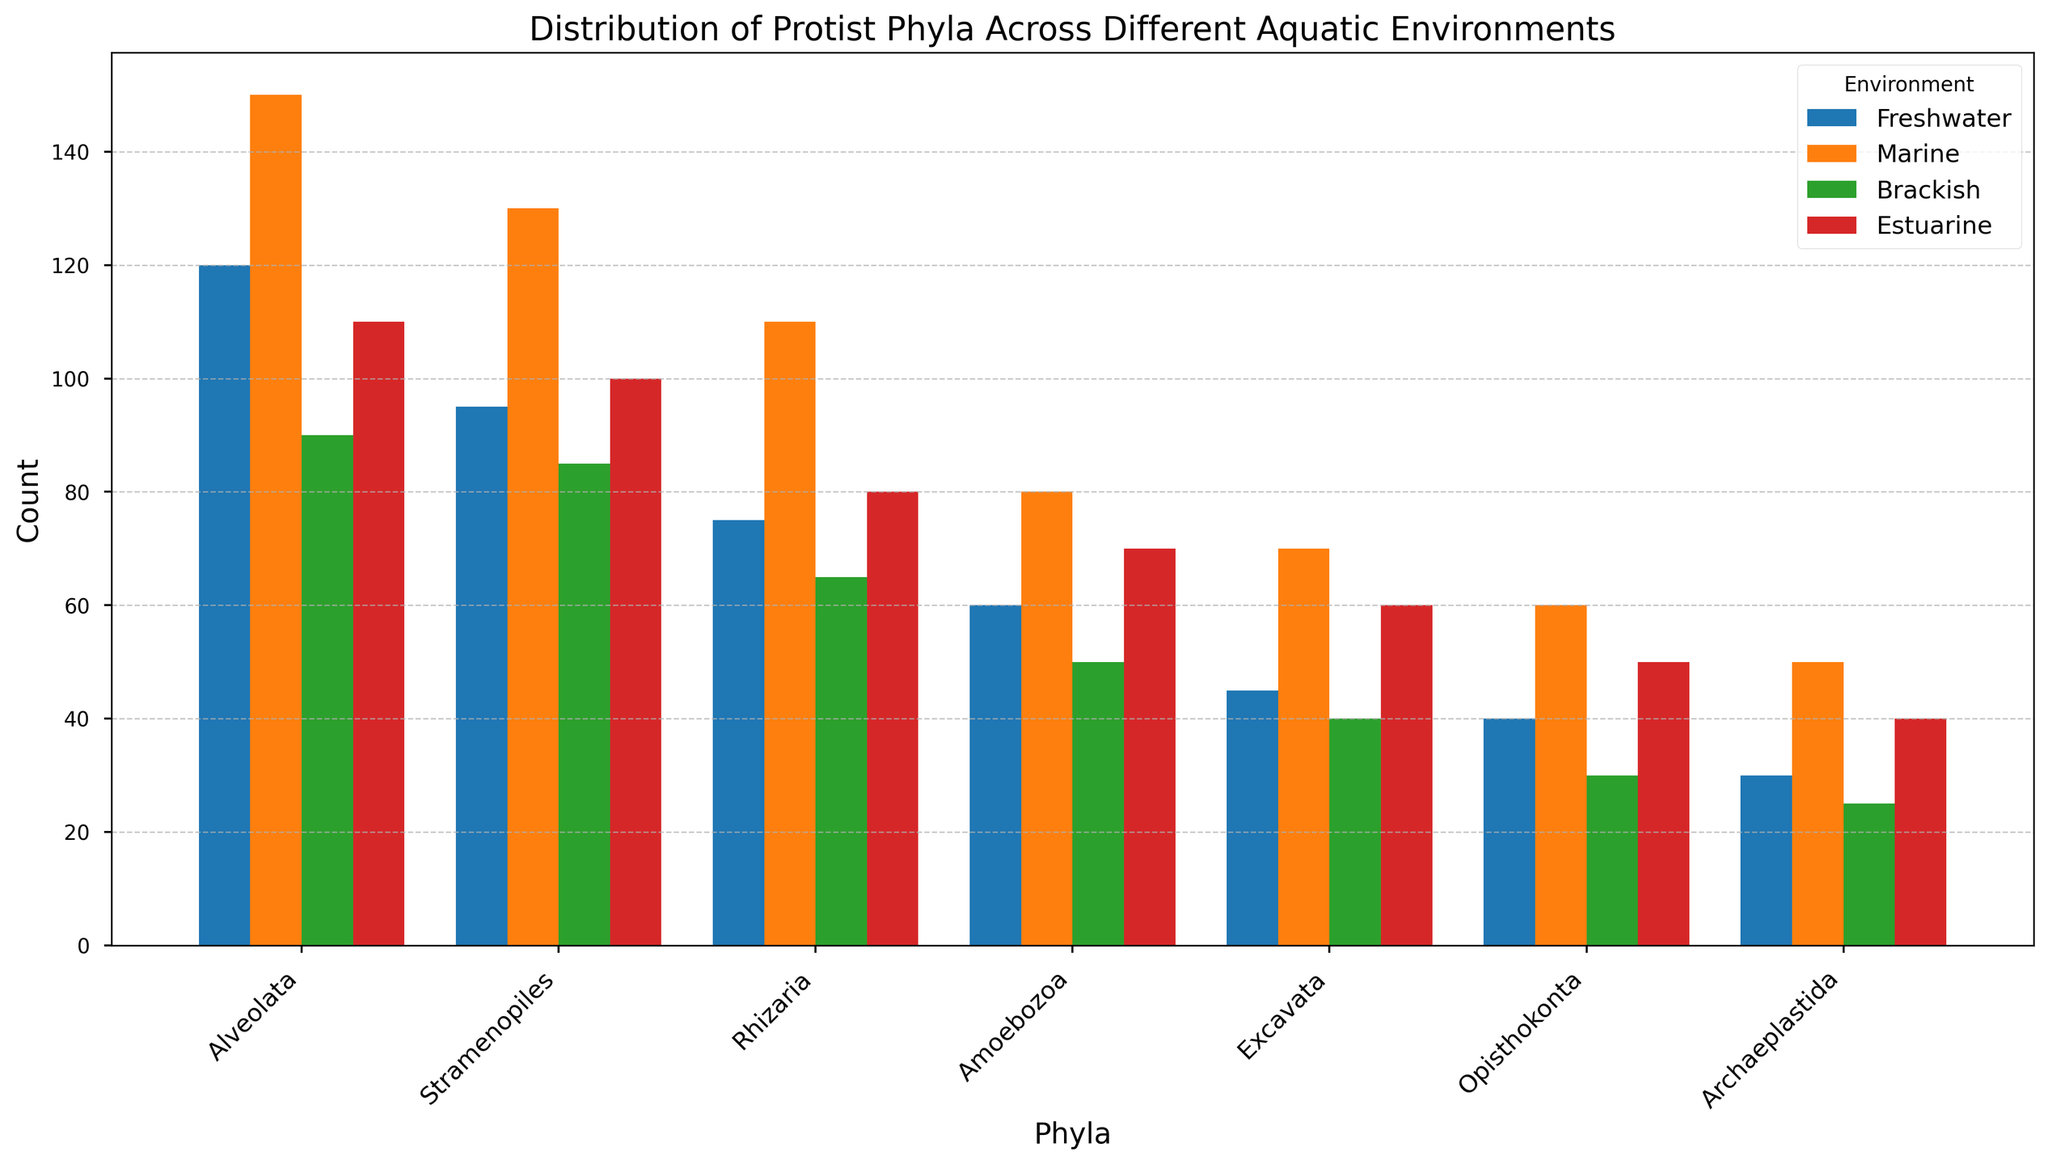Which environment has the highest count for Alveolata? Alveolata counts are shown as different colored bars for each environment. The highest bar for Alveolata is in the Marine environment.
Answer: Marine How does the count of Excavata in Freshwater compare to its count in Brackish? Locate the bars for Excavata in both Freshwater and Brackish environments. The bar for Freshwater is higher than the bar for Brackish.
Answer: Freshwater is higher Which phylum has the lowest count in the Estuarine environment? Look at the shortest bar in the Estuarine section. The Archaeplastida bar is the shortest.
Answer: Archaeplastida Compare the sum of counts for Amoebozoa in Freshwater and Marine environments. Add the counts of Amoebozoa in Freshwater (60) and Marine (80). The sum is 60 + 80 = 140.
Answer: 140 What is the difference in the count of Stramenopiles between Marine and Estuarine environments? Subtract the count of Stramenopiles in Estuarine (100) from Marine (130). The difference is 130 - 100 = 30.
Answer: 30 Are there any environments where the count of Rhizaria exceeds 100? Check each bar for Rhizaria. Only in the Marine environment, Rhizaria exceeds 100 with a count of 110.
Answer: Yes, Marine What is the average count of Opisthokonta across all environments? Add the counts of Opisthokonta in all environments (40+60+30+50) and divide by 4. The calculation is (40 + 60 + 30 + 50) / 4 = 45.
Answer: 45 Which environment shows the greatest diversity in counts among different phyla? Observe the height differences among bars within each environment. Estuarine shows varied counts compared to others.
Answer: Estuarine How does the count of Archaeplastida in Freshwater compare to that in Marine? Refer to the bars for Archaeplastida in both environments. Marine (50) has a higher count than Freshwater (30).
Answer: Marine is higher What’s the sum of counts in Freshwater for Alveolata, Stramenopiles, and Rhizaria? Add the counts: Alveolata (120), Stramenopiles (95), and Rhizaria (75) in Freshwater. The total is 120 + 95 + 75 = 290.
Answer: 290 